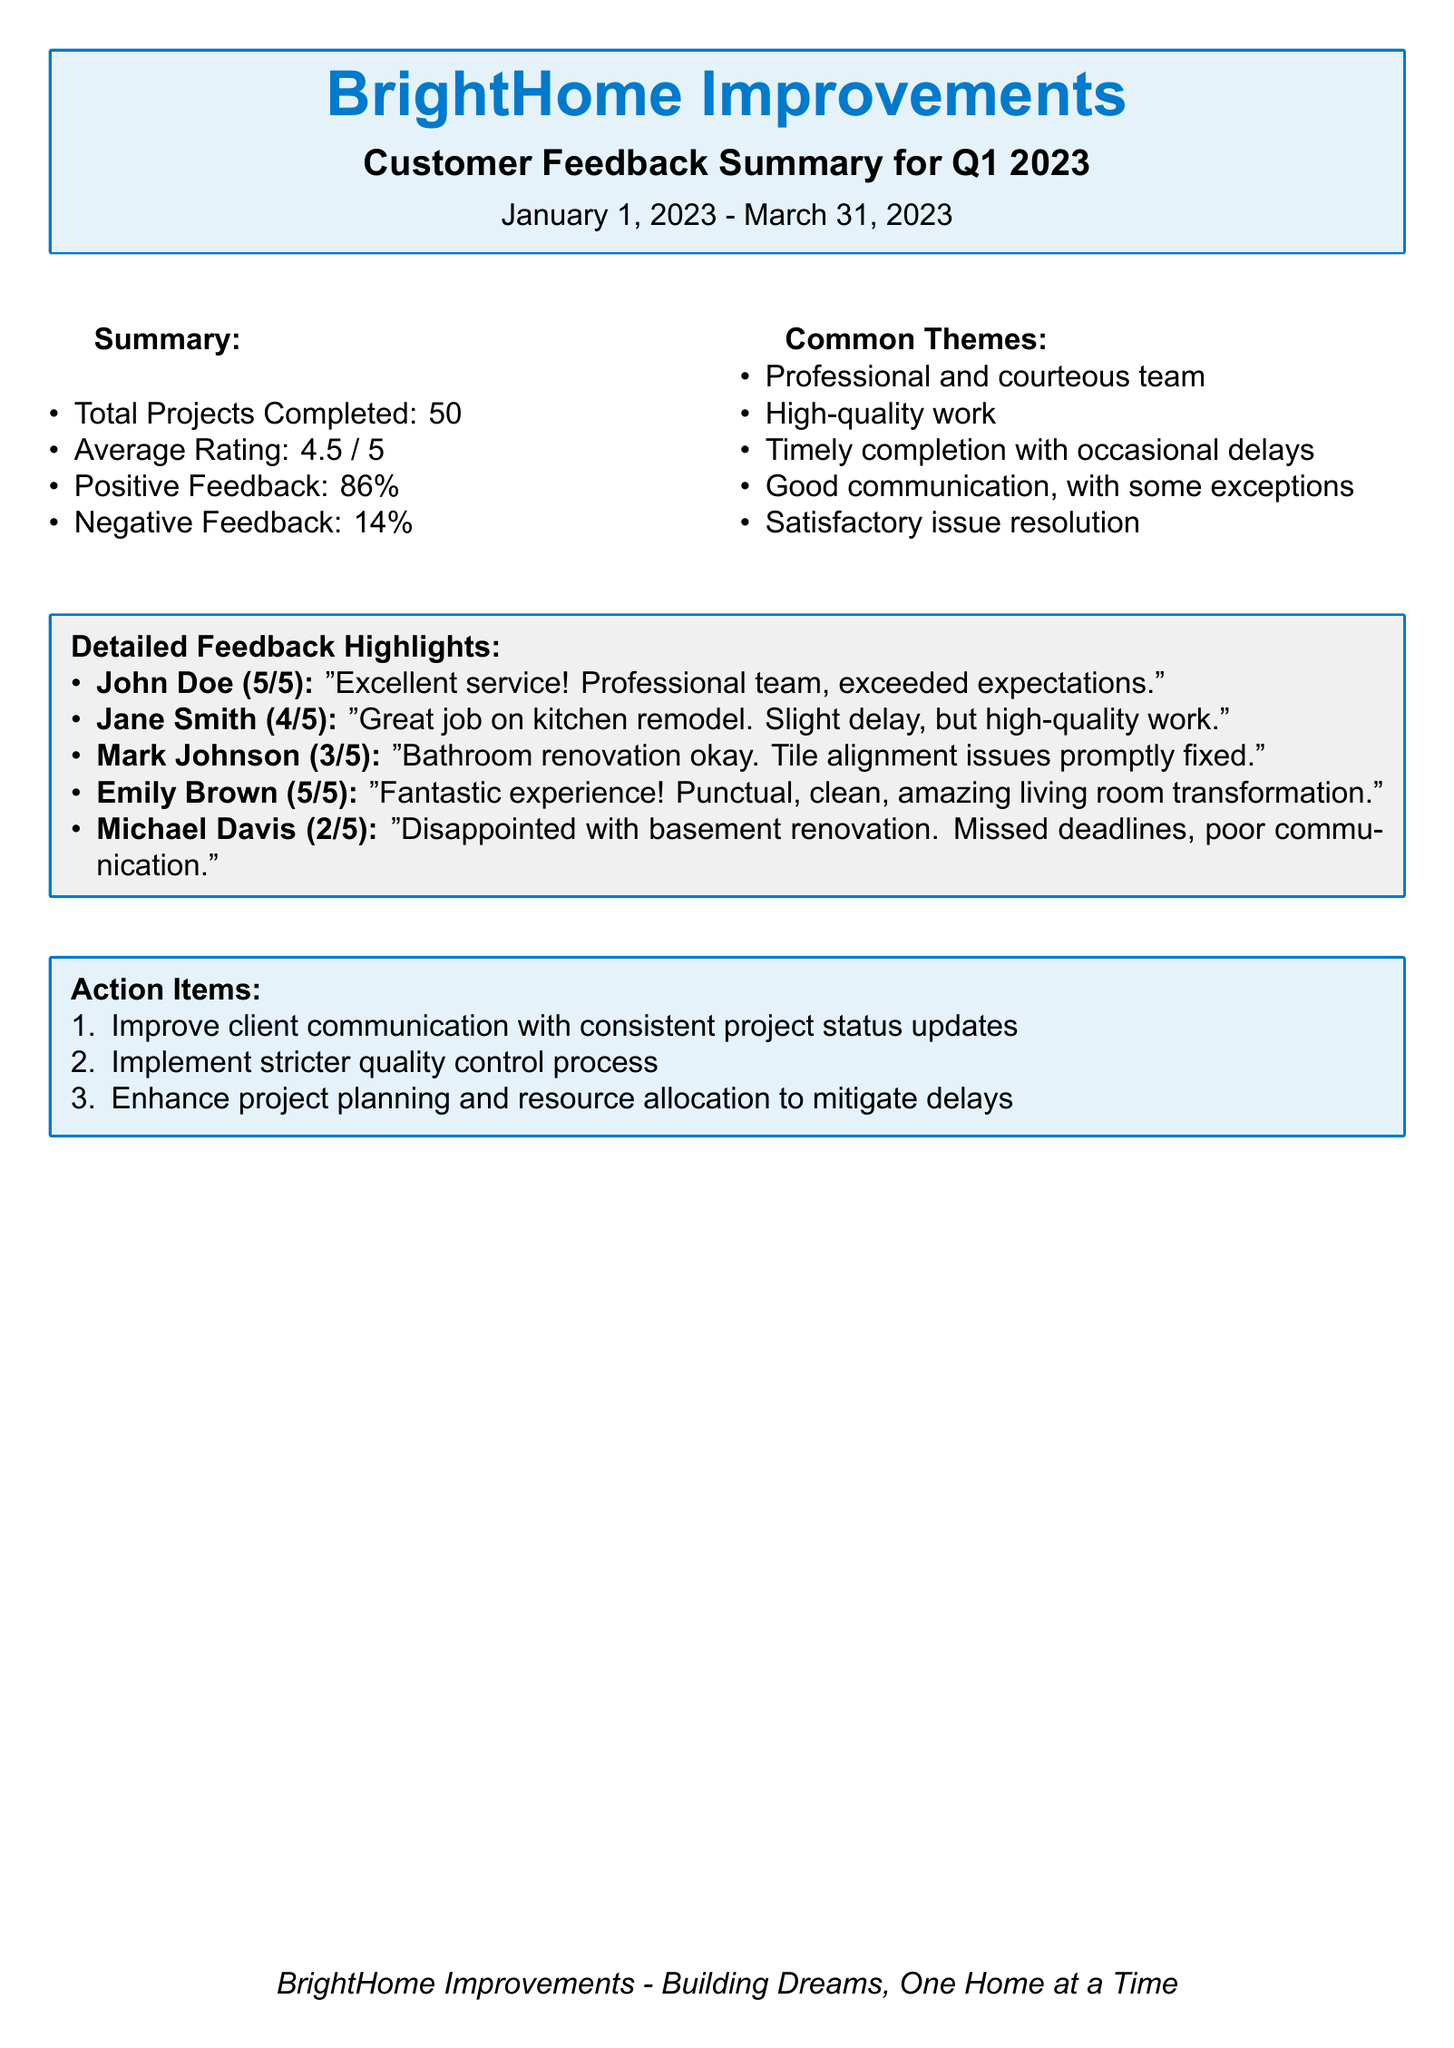What is the total number of projects completed? The total number of projects completed is stated in the summary section of the document.
Answer: 50 What is the average rating for the completed projects? The average rating is provided in the summary section of the document.
Answer: 4.5 / 5 What percentage of feedback was positive? The percentage of positive feedback is indicated in the summary section of the document.
Answer: 86% Who gave a rating of 2 out of 5? The feedback highlights list the names and ratings given by customers, including this rating.
Answer: Michael Davis What action item relates to communication? The action items section contains multiple points addressing various improvements, one of which directly addresses communication.
Answer: Improve client communication with consistent project status updates What theme is mentioned regarding completion times? The common themes section discusses various aspects of the service, including completion times.
Answer: Timely completion with occasional delays How many total pieces of feedback were collected? The total projects completed gives an indication of the number of feedback pieces available for analysis.
Answer: 50 What was a common issue noted in the feedback? The detailed feedback highlights note several themes, one of which describes an issue prevalent among comments.
Answer: Poor communication 